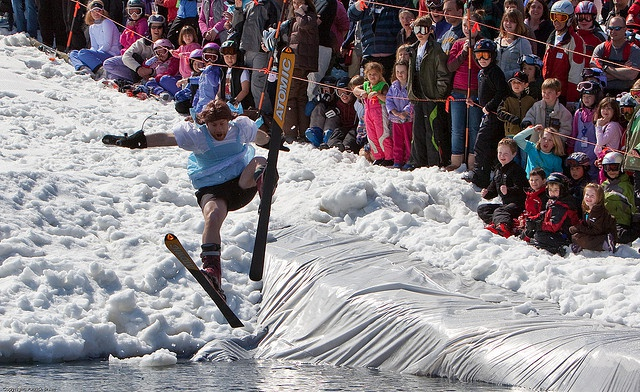Describe the objects in this image and their specific colors. I can see people in black, gray, maroon, and navy tones, people in black, gray, and blue tones, skis in black, maroon, brown, and gray tones, people in black, gray, maroon, and darkgreen tones, and people in black, gray, and maroon tones in this image. 